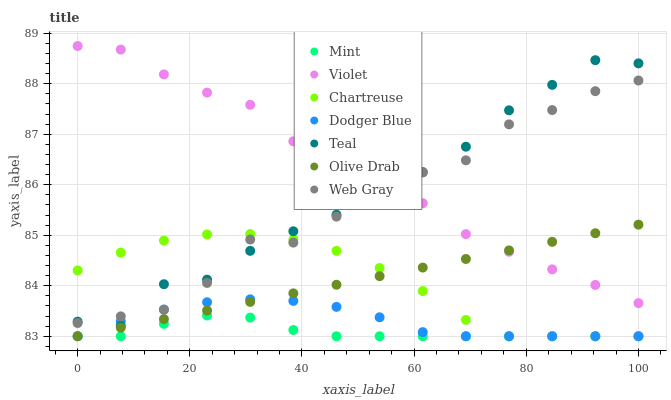Does Mint have the minimum area under the curve?
Answer yes or no. Yes. Does Violet have the maximum area under the curve?
Answer yes or no. Yes. Does Chartreuse have the minimum area under the curve?
Answer yes or no. No. Does Chartreuse have the maximum area under the curve?
Answer yes or no. No. Is Olive Drab the smoothest?
Answer yes or no. Yes. Is Teal the roughest?
Answer yes or no. Yes. Is Chartreuse the smoothest?
Answer yes or no. No. Is Chartreuse the roughest?
Answer yes or no. No. Does Chartreuse have the lowest value?
Answer yes or no. Yes. Does Teal have the lowest value?
Answer yes or no. No. Does Violet have the highest value?
Answer yes or no. Yes. Does Chartreuse have the highest value?
Answer yes or no. No. Is Mint less than Teal?
Answer yes or no. Yes. Is Web Gray greater than Mint?
Answer yes or no. Yes. Does Olive Drab intersect Chartreuse?
Answer yes or no. Yes. Is Olive Drab less than Chartreuse?
Answer yes or no. No. Is Olive Drab greater than Chartreuse?
Answer yes or no. No. Does Mint intersect Teal?
Answer yes or no. No. 